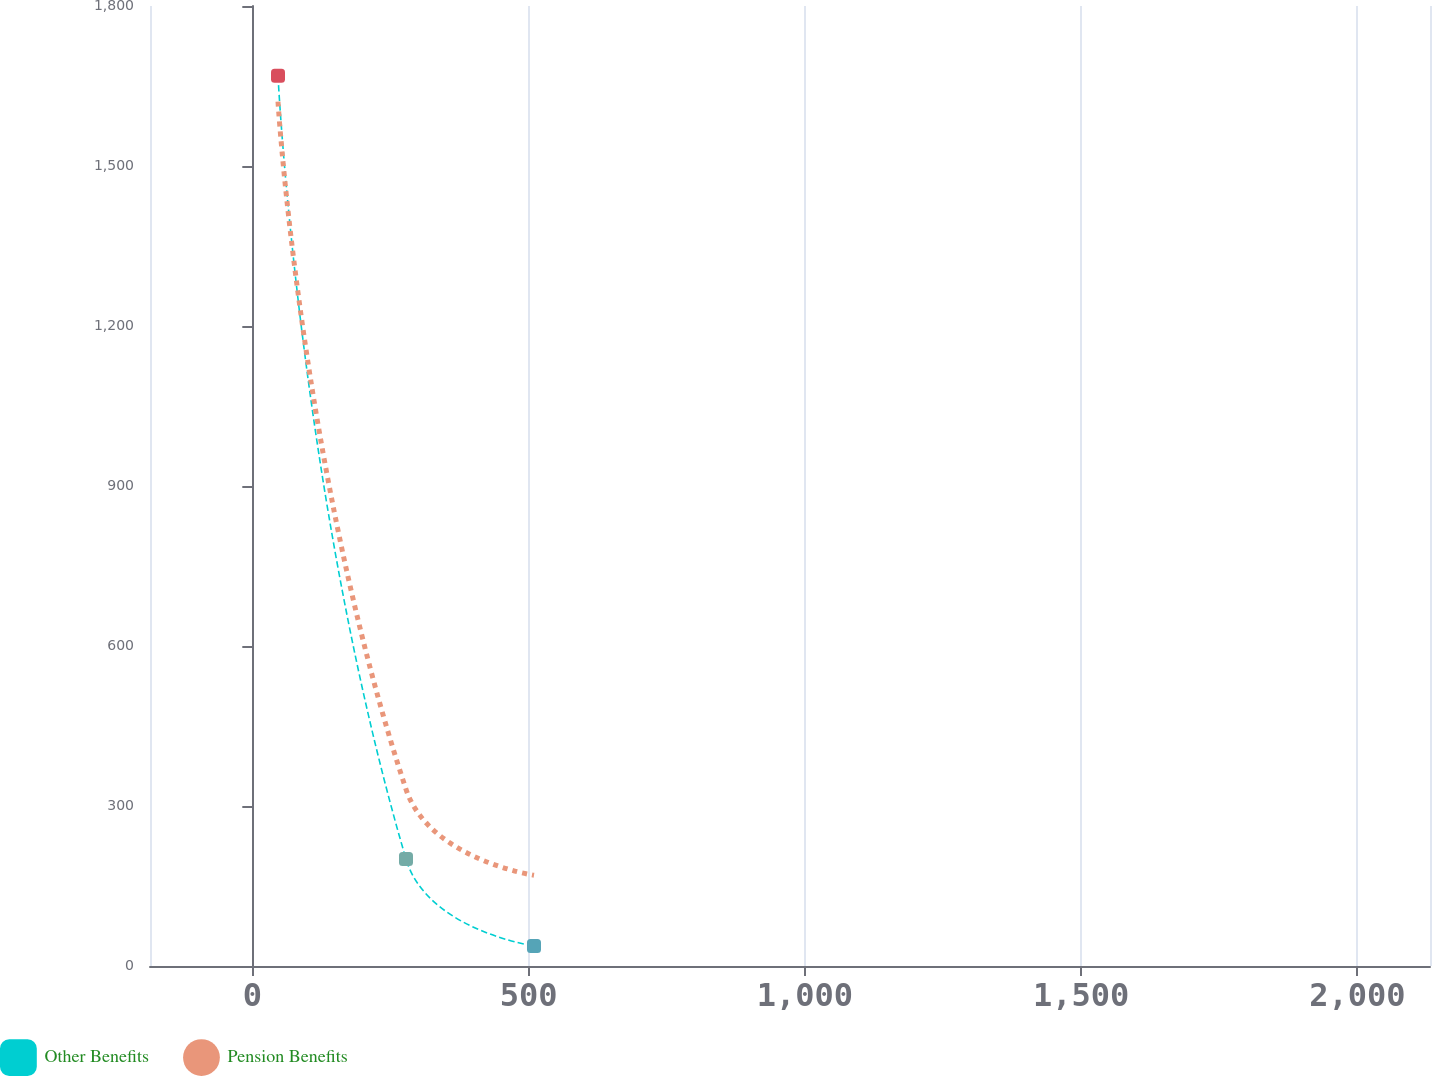<chart> <loc_0><loc_0><loc_500><loc_500><line_chart><ecel><fcel>Other Benefits<fcel>Pension Benefits<nl><fcel>46.5<fcel>1669.29<fcel>1620.68<nl><fcel>278.14<fcel>200.62<fcel>331.32<nl><fcel>509.78<fcel>37.43<fcel>170.15<nl><fcel>2362.95<fcel>363.81<fcel>8.98<nl></chart> 